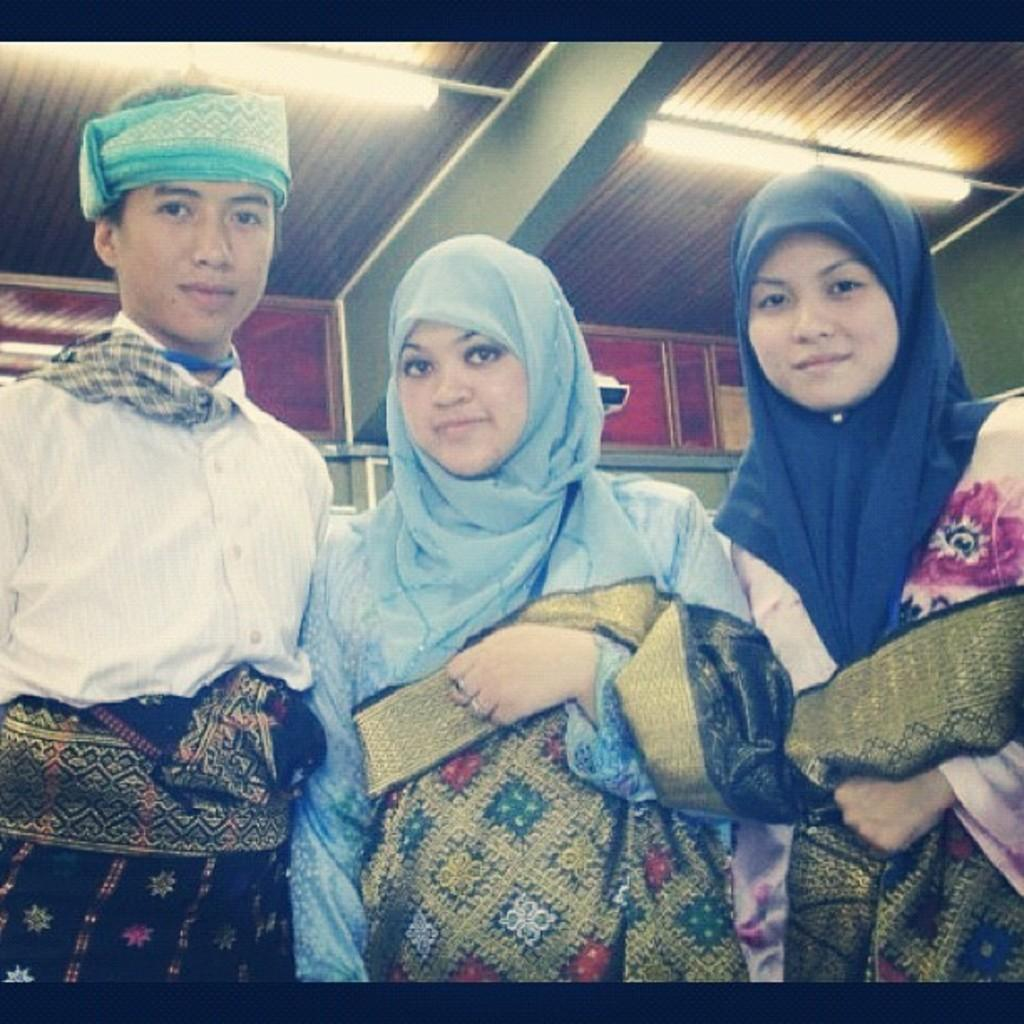How many people are in the image? There are two women and a man in the image, making a total of three individuals. What are the people in the image doing? The individuals are standing together and posing for a photograph. What can be seen at the top of the image? There are lights visible at the top of the image. What type of structure is present in the image? There is a roof in the image. How does the dock appear in the image? There is no dock present in the image. What action is the man performing in the image? The man, along with the two women, is posing for a photograph. 